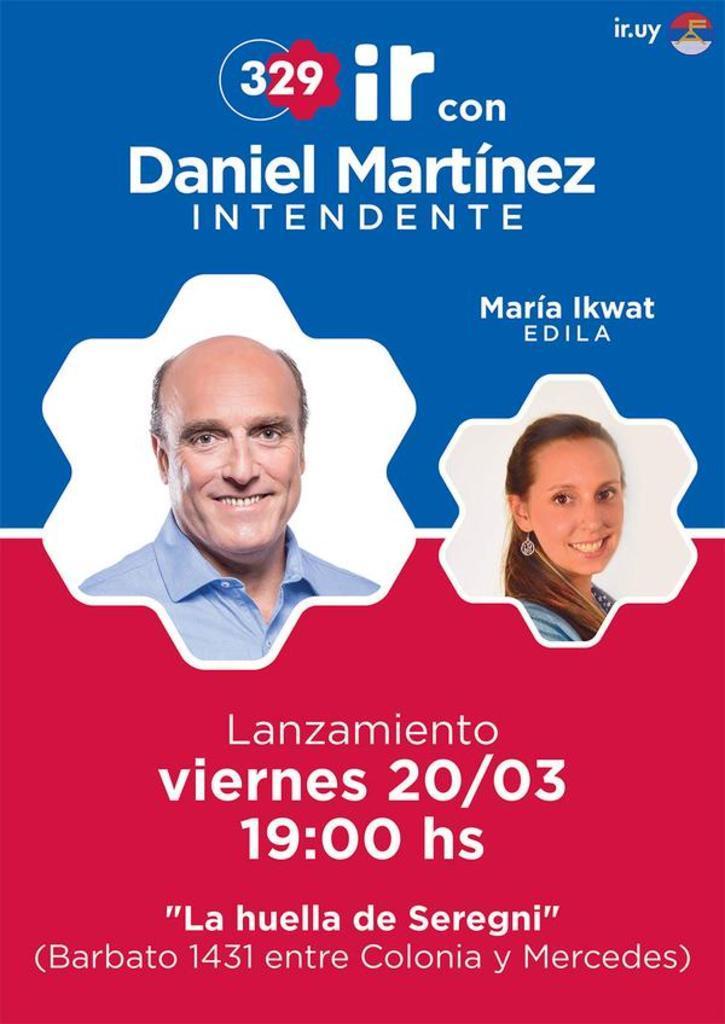Could you give a brief overview of what you see in this image? In this image there is a man and a woman and there is some text. 